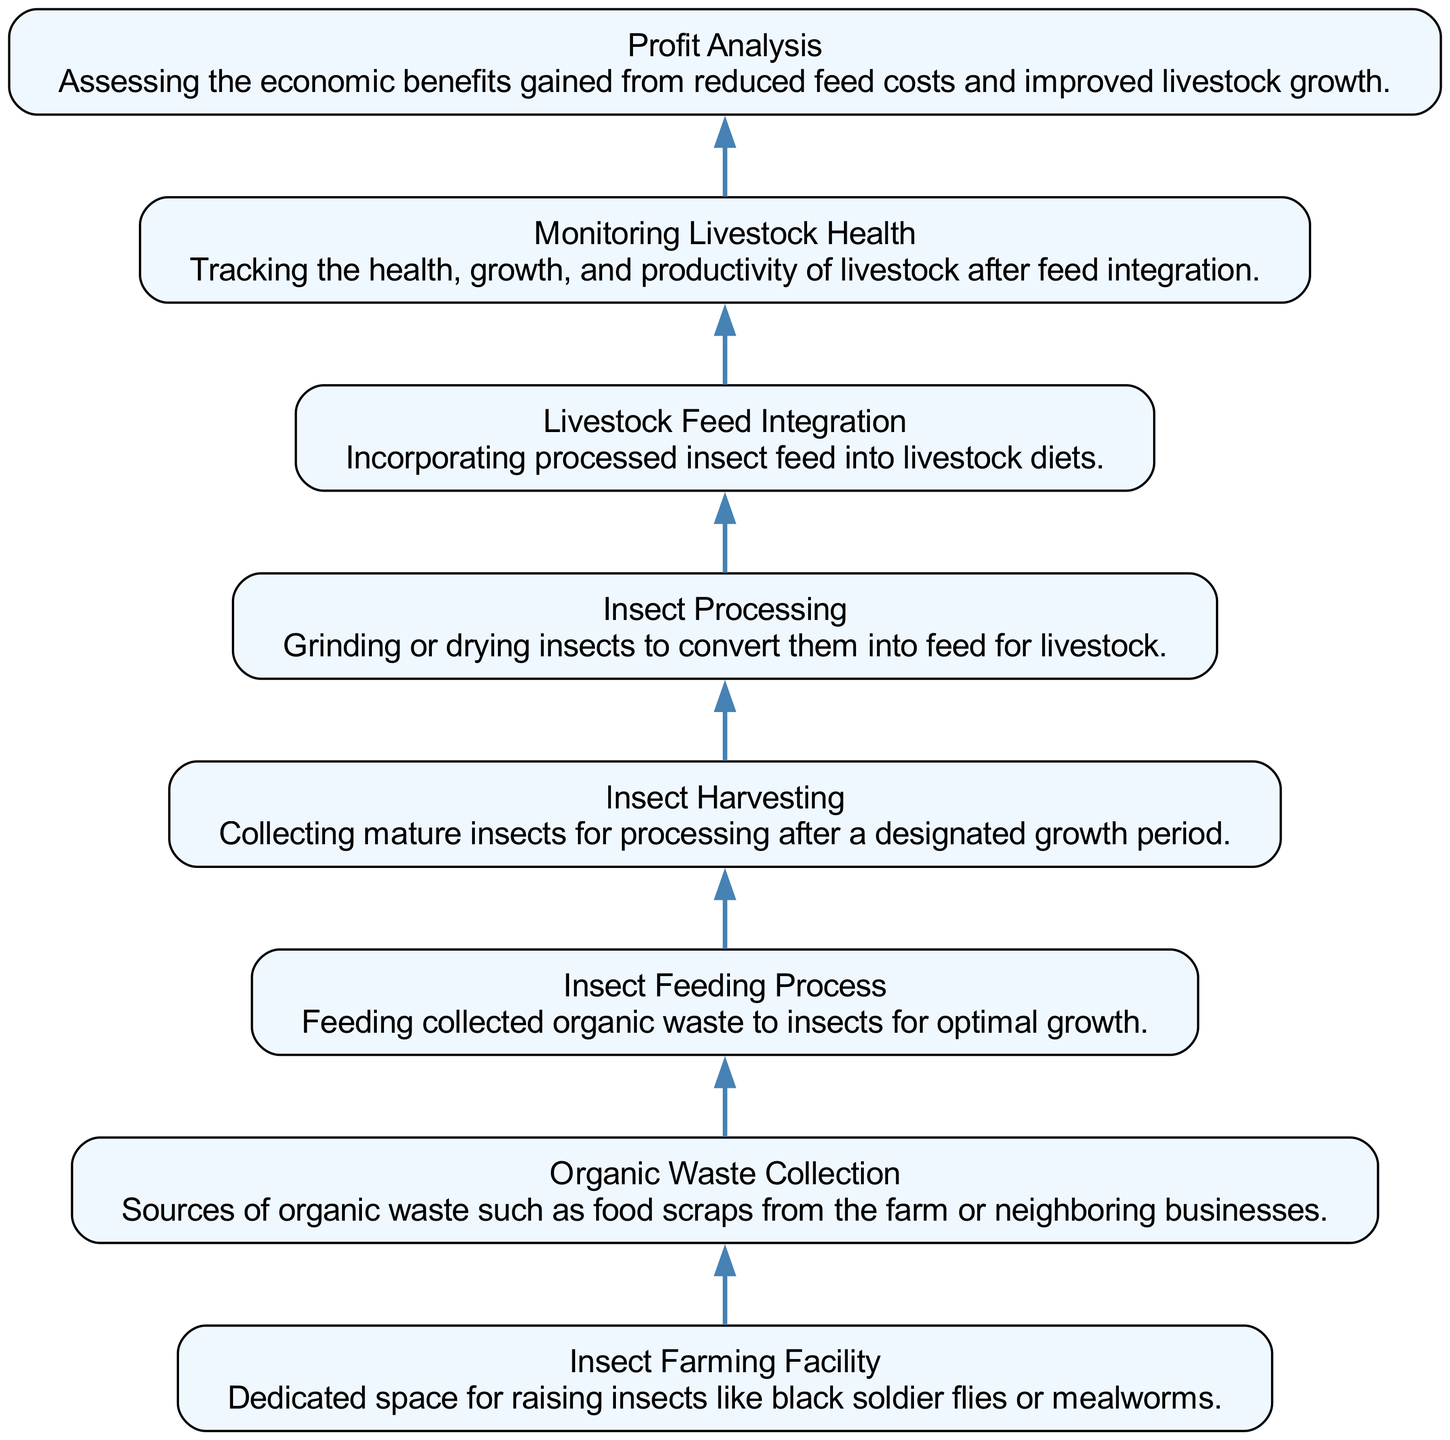What is the first step in the insect feed conversion process? The first step shown in the diagram is "Insect Farming Facility," which serves as the dedicated space for raising insects.
Answer: Insect Farming Facility How many nodes are in the diagram? By counting the elements represented in the diagram, there are eight nodes.
Answer: Eight What is the relationship between "Organic Waste Collection" and "Insect Feeding Process"? "Organic Waste Collection" is directly connected to "Insect Feeding Process," indicating that collected organic waste is fed to insects for growth.
Answer: Organic Waste Collection Which node follows "Insect Harvesting"? Following "Insect Harvesting" in the flow is "Insect Processing," which involves grinding or drying the collected insects.
Answer: Insect Processing What is assessed during the "Profit Analysis"? The "Profit Analysis" assesses the economic benefits gained from reduced feed costs and improved livestock growth after implementing insect feed.
Answer: Economic benefits What is the main purpose of the "Monitoring Livestock Health" step? The main purpose of "Monitoring Livestock Health" is to track the health, growth, and productivity of livestock after the integration of insect feed.
Answer: Track health, growth, and productivity Which node represents the final step in the process? The final step in the process, as shown in the diagram, is "Profit Analysis," which evaluates the outcomes of the previous steps.
Answer: Profit Analysis How does "Insect Processing" contribute to livestock feeding? "Insect Processing" converts the harvested insects into feed, which can then be integrated into livestock diets to support their nutrition.
Answer: Converts insects into feed What type of organic waste is collected? The collected organic waste comes from sources like food scraps from the farm or neighboring businesses.
Answer: Food scraps 